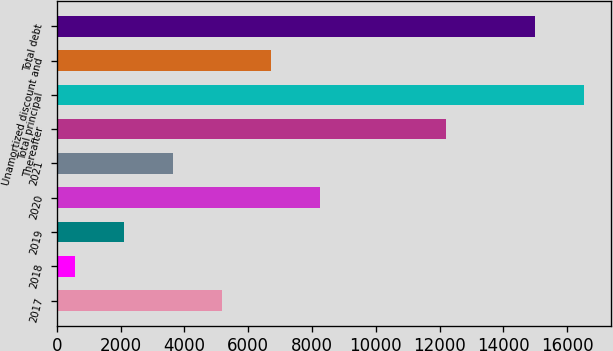Convert chart to OTSL. <chart><loc_0><loc_0><loc_500><loc_500><bar_chart><fcel>2017<fcel>2018<fcel>2019<fcel>2020<fcel>2021<fcel>Thereafter<fcel>Total principal<fcel>Unamortized discount and<fcel>Total debt<nl><fcel>5170.7<fcel>572<fcel>2104.9<fcel>8236.5<fcel>3637.8<fcel>12206<fcel>16539.9<fcel>6703.6<fcel>15007<nl></chart> 